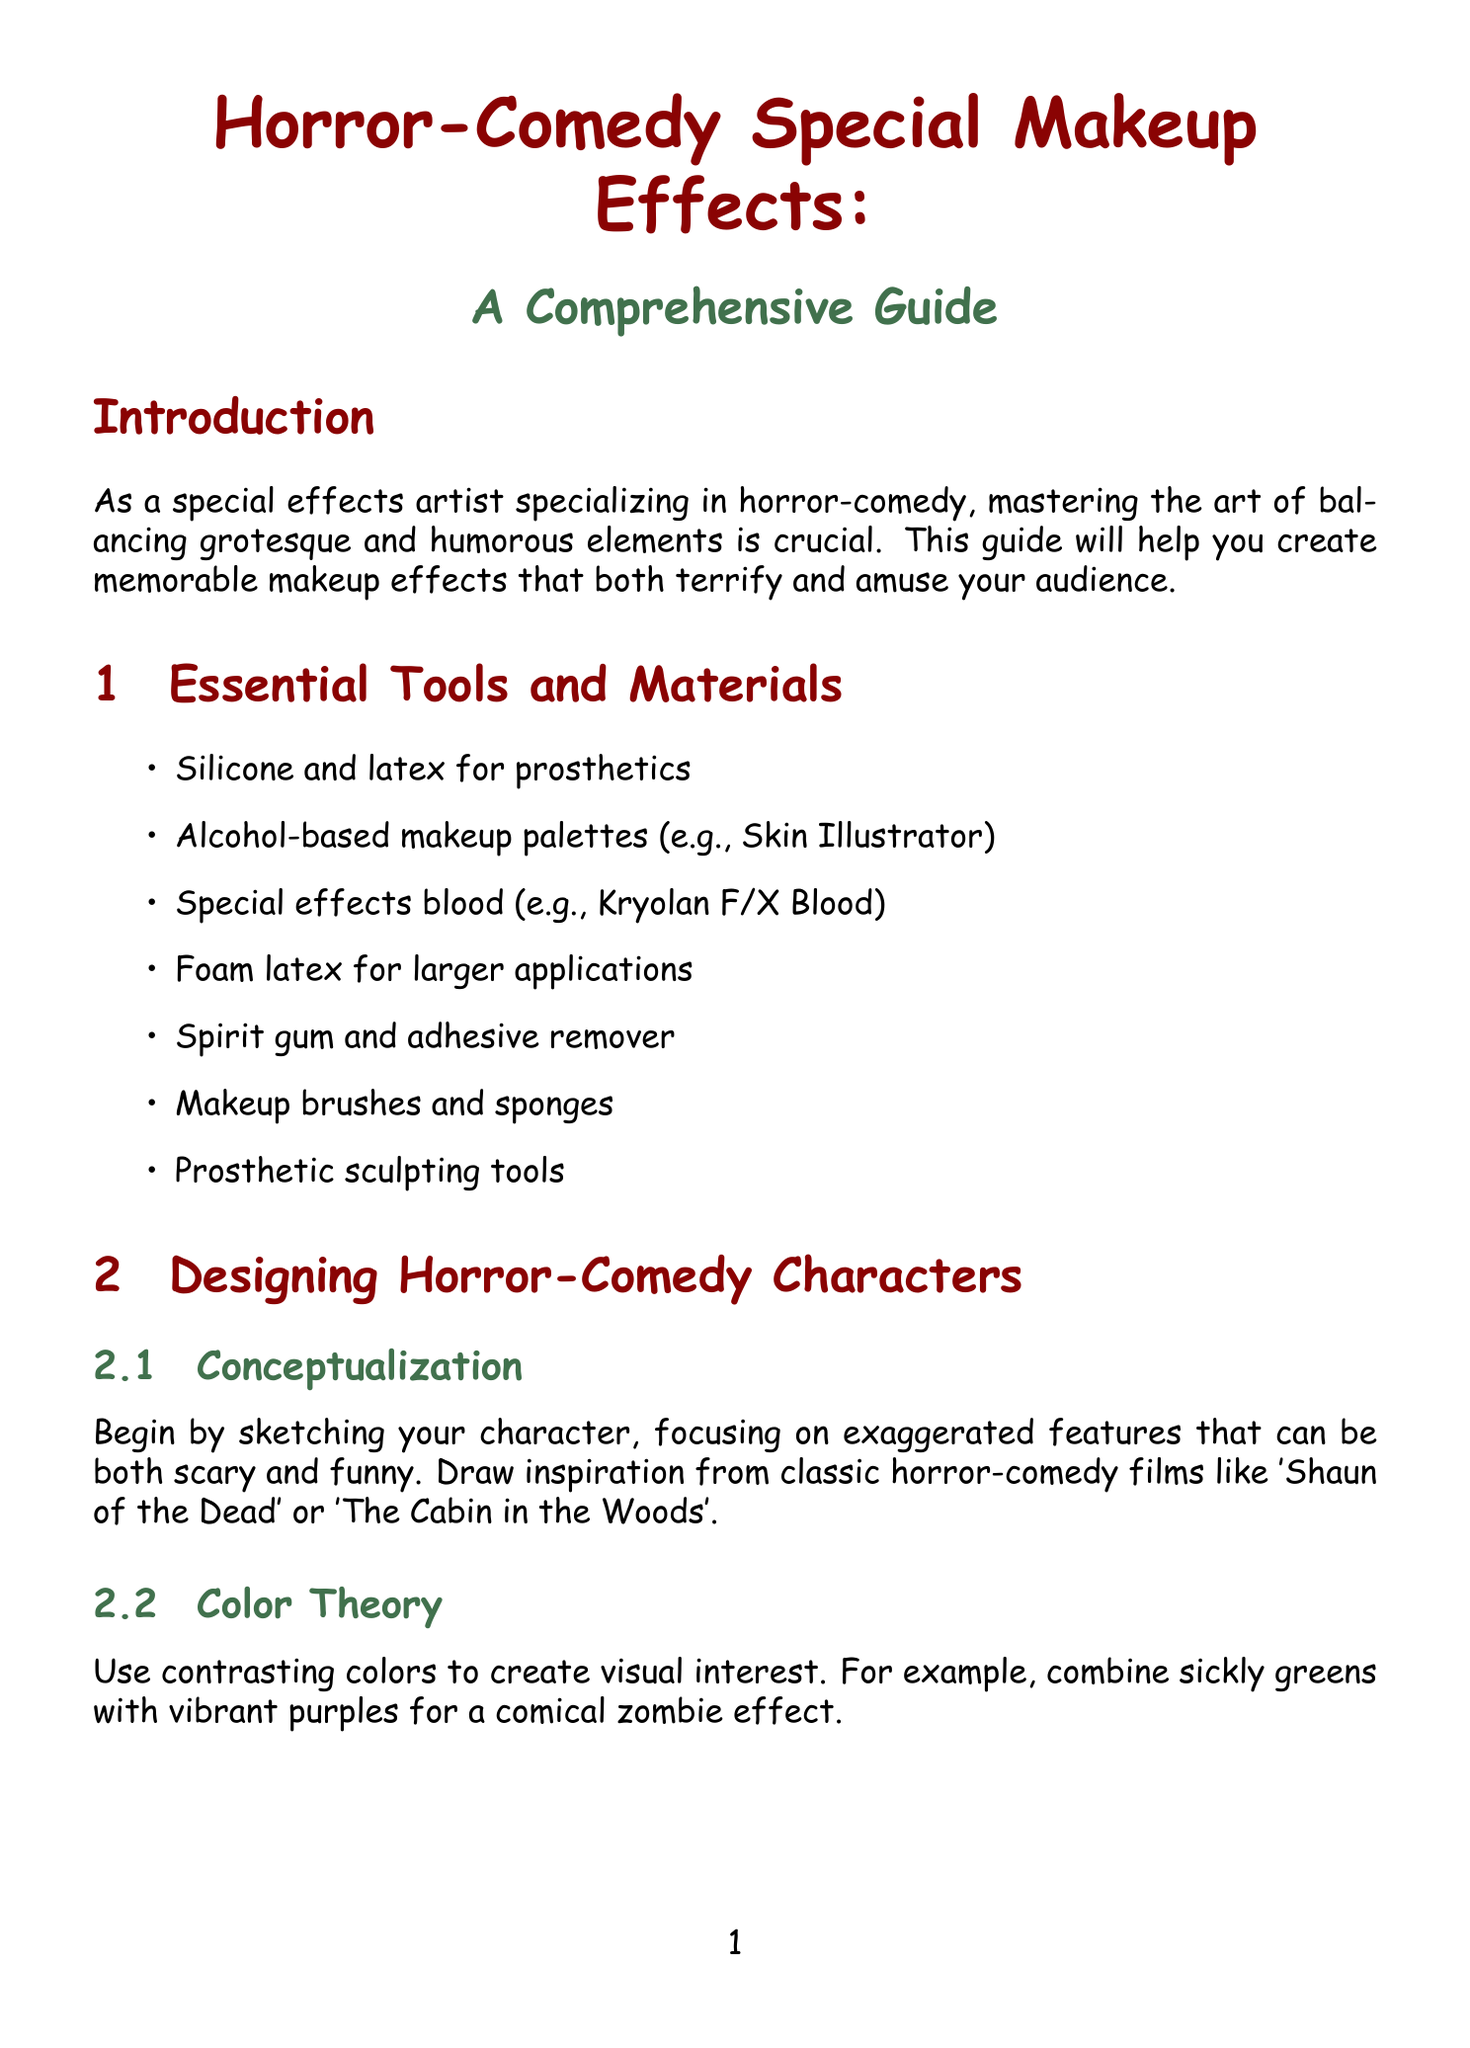What are the primary materials used for prosthetics? The document lists specific materials such as silicone and latex for prosthetics.
Answer: Silicone and latex What is the first step in creating and applying prosthetics? The first step mentioned in the document is to sculpt the prosthetic piece using Monster Clay or WED clay.
Answer: Sculpt the prosthetic piece What technique is used for creating texture and depth by stippling? The technique of stippling is detailed in the makeup application techniques section for creating texture.
Answer: Stippling Which character requires oversized cartoonish fangs? The section on special effects for specific creatures mentions a comical vampire who requires oversized fangs.
Answer: Comical Vampire What color is used for the 'blood' in the comical vampire makeup? The document specifies the use of bright red for the 'blood' on the comical vampire.
Answer: Bright red How many tips are provided for the bumbling werewolf? There are three tips specifically listed for creating a bumbling werewolf.
Answer: Three tips What is the purpose of using a fan on set? The document mentions using a small fan to keep prosthetics cool and prevent sweating.
Answer: Prevent sweating What should be done after removing prosthetics? The skin should be cleaned with isopropyl myristate followed by a gentle cleanser after prosthetics are removed.
Answer: Clean the actor's skin What is the primary goal of this guide? The introduction states that the goal is to help create memorable makeup effects that terrify and amuse audiences.
Answer: Create memorable makeup effects 